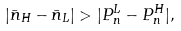<formula> <loc_0><loc_0><loc_500><loc_500>| \bar { n } _ { H } - \bar { n } _ { L } | > | P ^ { L } _ { n } - P ^ { H } _ { n } | ,</formula> 